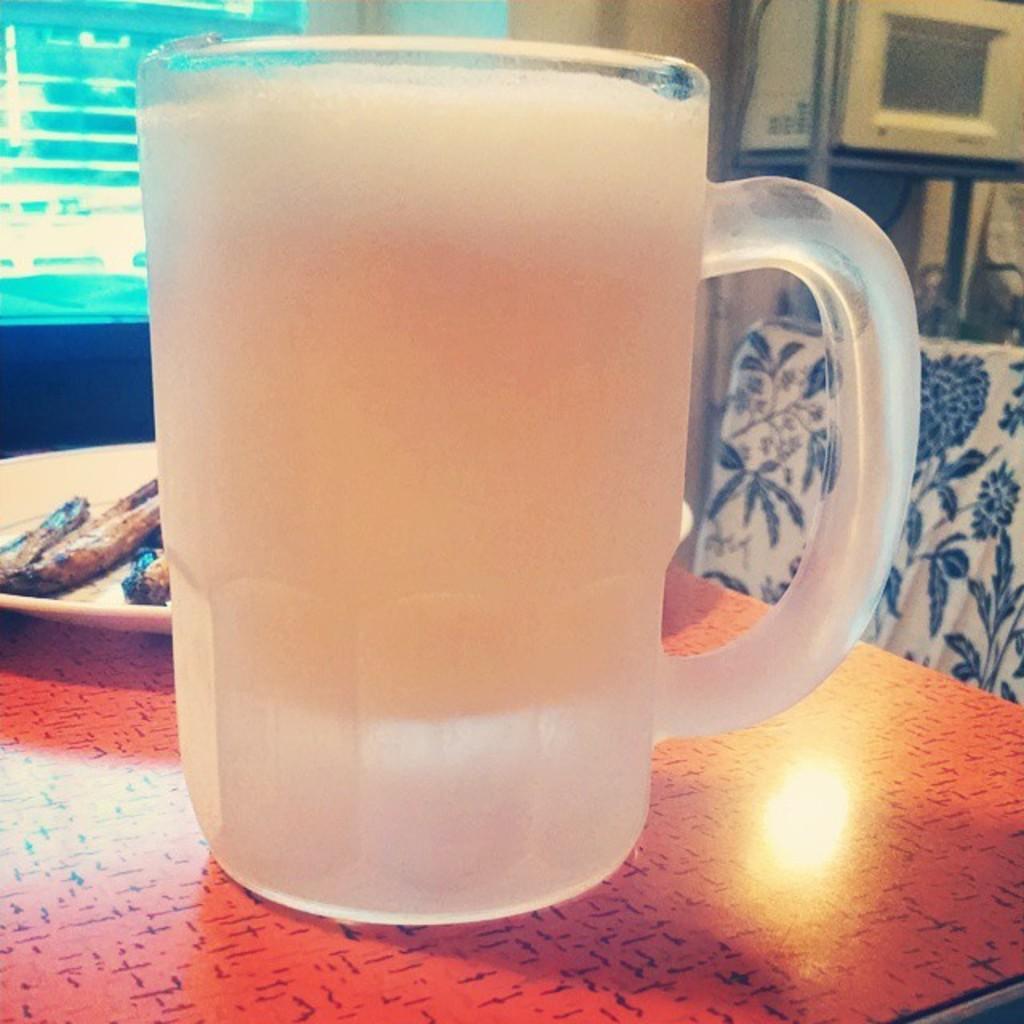Could you give a brief overview of what you see in this image? In this picture I can observe a mug placed on the table in the middle of the picture. Behind the mug I can observe a plate on the table. 